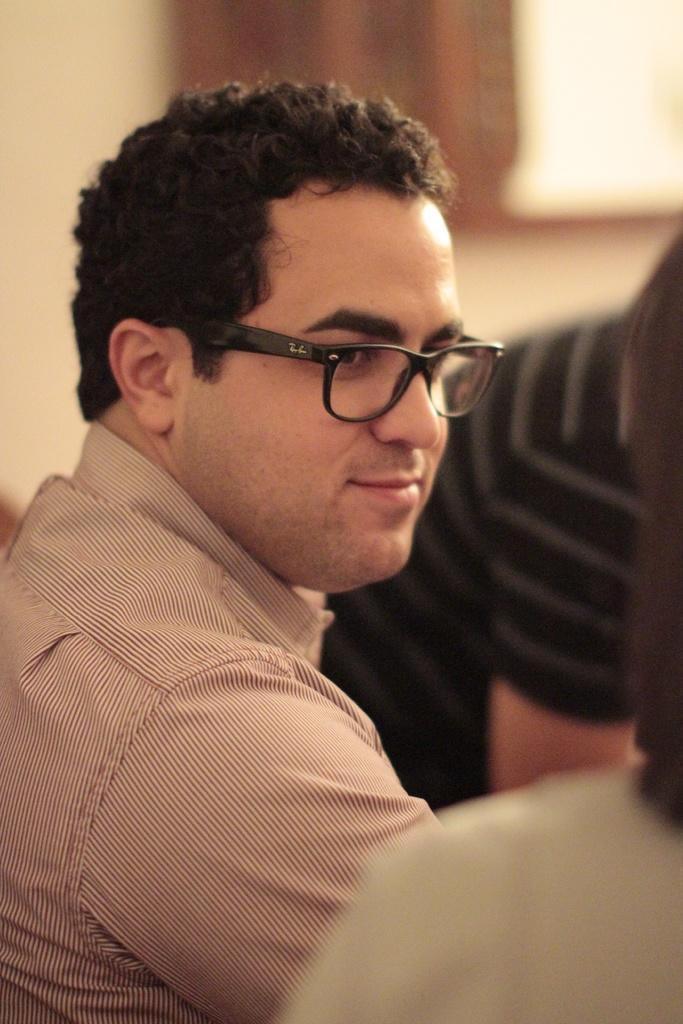Can you describe this image briefly? In this image I can see people among them this man is wearing a shirt and spectacles. The background of the image is blurred. 